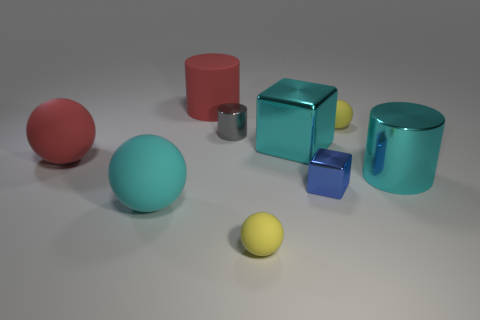Subtract 1 cylinders. How many cylinders are left? 2 Subtract all small rubber balls. Subtract all tiny metallic blocks. How many objects are left? 6 Add 3 large rubber balls. How many large rubber balls are left? 5 Add 8 large cyan balls. How many large cyan balls exist? 9 Add 1 tiny rubber balls. How many objects exist? 10 Subtract all yellow spheres. How many spheres are left? 2 Subtract all large red spheres. How many spheres are left? 3 Subtract 0 brown cubes. How many objects are left? 9 Subtract all cylinders. How many objects are left? 6 Subtract all red balls. Subtract all yellow cubes. How many balls are left? 3 